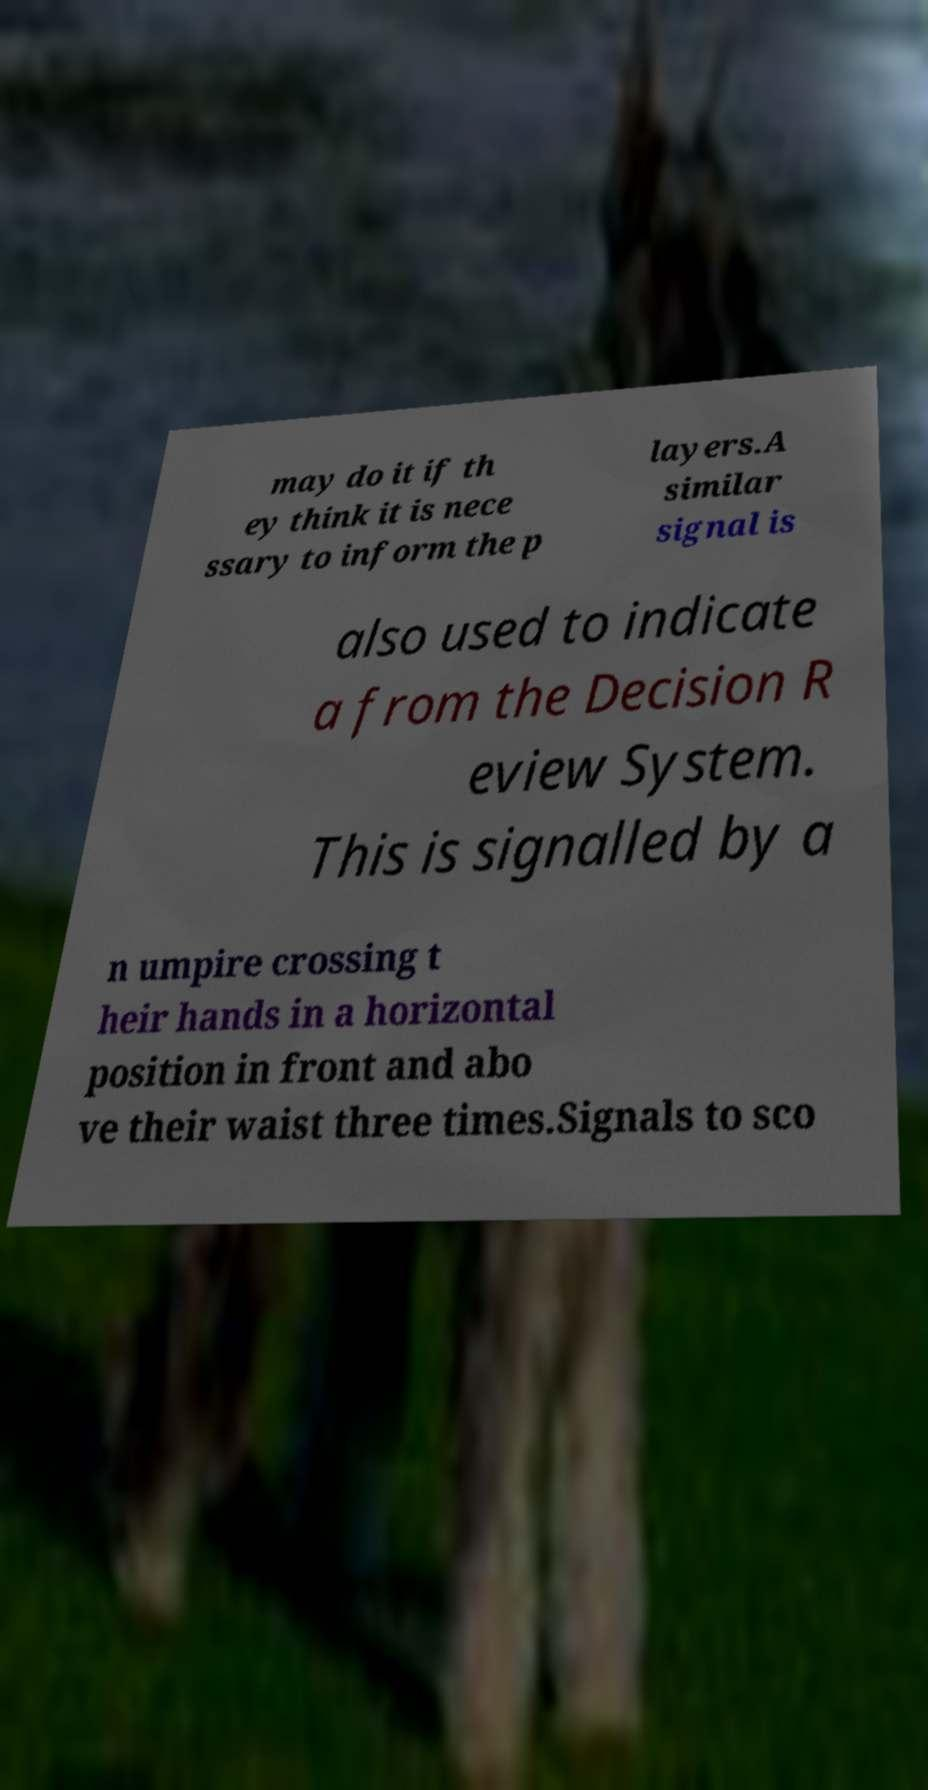What messages or text are displayed in this image? I need them in a readable, typed format. may do it if th ey think it is nece ssary to inform the p layers.A similar signal is also used to indicate a from the Decision R eview System. This is signalled by a n umpire crossing t heir hands in a horizontal position in front and abo ve their waist three times.Signals to sco 